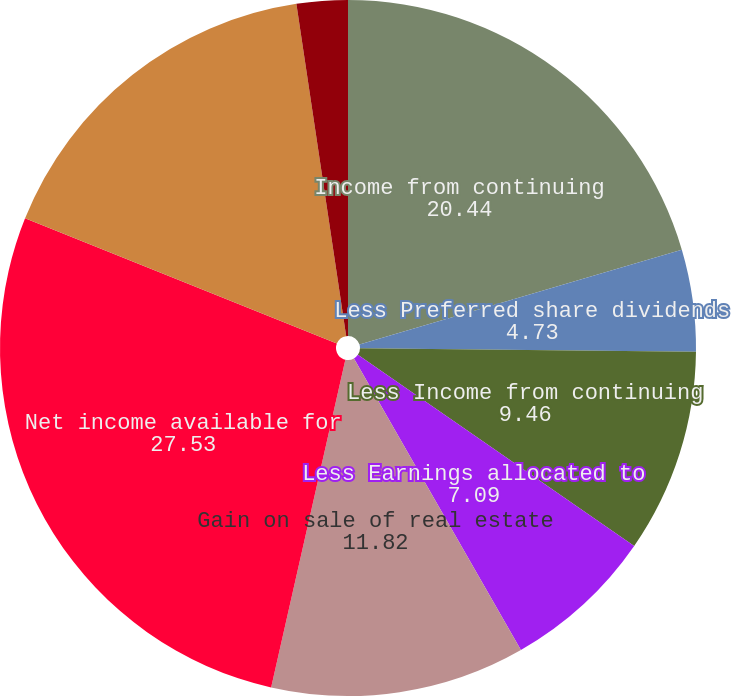Convert chart to OTSL. <chart><loc_0><loc_0><loc_500><loc_500><pie_chart><fcel>Income from continuing<fcel>Less Preferred share dividends<fcel>Less Income from continuing<fcel>Less Earnings allocated to<fcel>Gain on sale of real estate<fcel>Net income available for<fcel>Weighted average common shares<fcel>Stock options<nl><fcel>20.44%<fcel>4.73%<fcel>9.46%<fcel>7.09%<fcel>11.82%<fcel>27.53%<fcel>16.55%<fcel>2.37%<nl></chart> 